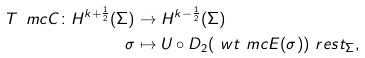<formula> <loc_0><loc_0><loc_500><loc_500>T _ { \ } m c C \colon H ^ { k + \frac { 1 } { 2 } } ( \Sigma ) & \to H ^ { k - \frac { 1 } { 2 } } ( \Sigma ) \\ \sigma & \mapsto U \circ D _ { 2 } ( \ w t \ m c E ( \sigma ) ) \ r e s t _ { \Sigma } ,</formula> 